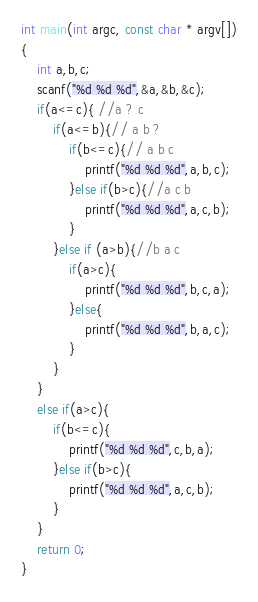<code> <loc_0><loc_0><loc_500><loc_500><_C_>int main(int argc, const char * argv[])
{
    int a,b,c;
    scanf("%d %d %d",&a,&b,&c);
    if(a<=c){ //a ? c
        if(a<=b){// a b ?
            if(b<=c){// a b c
                printf("%d %d %d",a,b,c);
            }else if(b>c){//a c b
                printf("%d %d %d",a,c,b);
            }
        }else if (a>b){//b a c
            if(a>c){
                printf("%d %d %d",b,c,a);
            }else{
                printf("%d %d %d",b,a,c);
            }
        }
    }
    else if(a>c){
        if(b<=c){
            printf("%d %d %d",c,b,a);
        }else if(b>c){
            printf("%d %d %d",a,c,b);
        }
    }
    return 0;
}</code> 